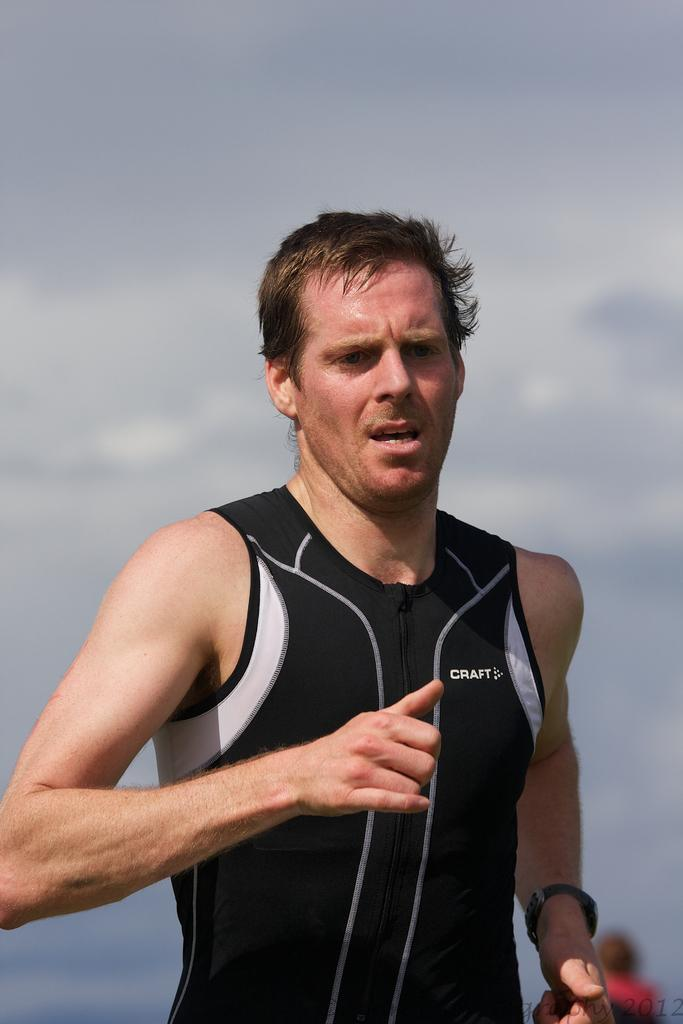<image>
Render a clear and concise summary of the photo. A white, middle aged man appears to be jogging, in a black and white CRAFT, tank top. 